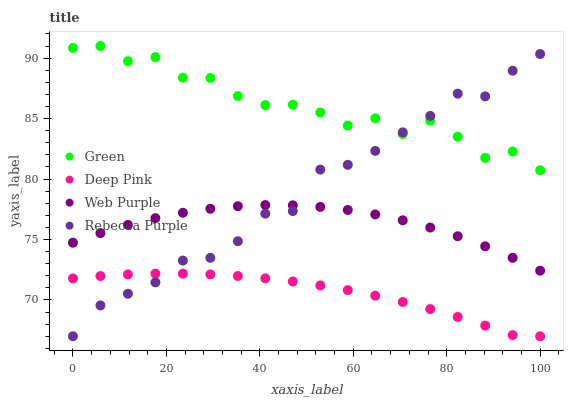Does Deep Pink have the minimum area under the curve?
Answer yes or no. Yes. Does Green have the maximum area under the curve?
Answer yes or no. Yes. Does Green have the minimum area under the curve?
Answer yes or no. No. Does Deep Pink have the maximum area under the curve?
Answer yes or no. No. Is Deep Pink the smoothest?
Answer yes or no. Yes. Is Green the roughest?
Answer yes or no. Yes. Is Green the smoothest?
Answer yes or no. No. Is Deep Pink the roughest?
Answer yes or no. No. Does Deep Pink have the lowest value?
Answer yes or no. Yes. Does Green have the lowest value?
Answer yes or no. No. Does Green have the highest value?
Answer yes or no. Yes. Does Deep Pink have the highest value?
Answer yes or no. No. Is Deep Pink less than Green?
Answer yes or no. Yes. Is Green greater than Web Purple?
Answer yes or no. Yes. Does Rebecca Purple intersect Deep Pink?
Answer yes or no. Yes. Is Rebecca Purple less than Deep Pink?
Answer yes or no. No. Is Rebecca Purple greater than Deep Pink?
Answer yes or no. No. Does Deep Pink intersect Green?
Answer yes or no. No. 